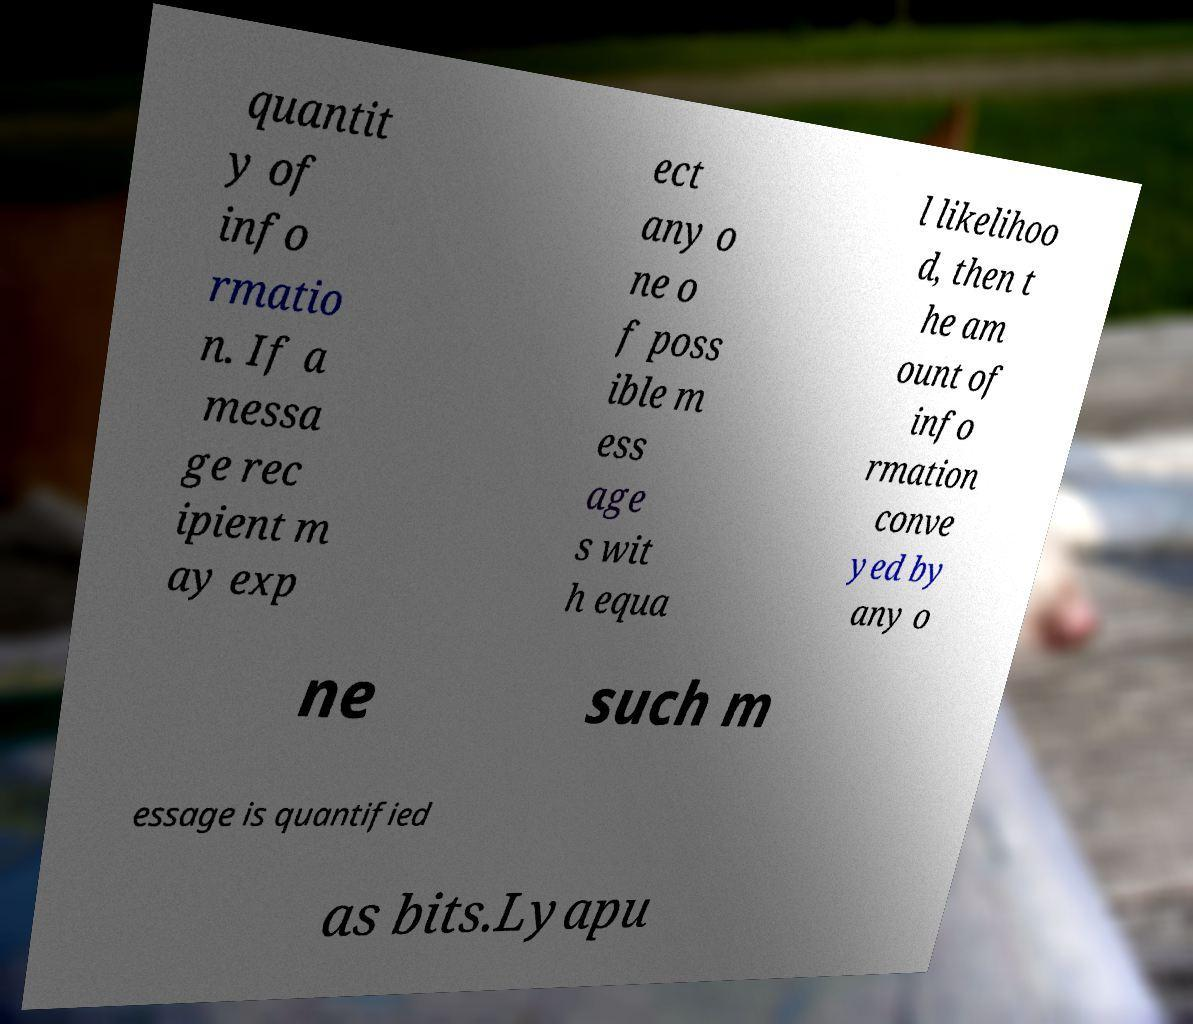There's text embedded in this image that I need extracted. Can you transcribe it verbatim? quantit y of info rmatio n. If a messa ge rec ipient m ay exp ect any o ne o f poss ible m ess age s wit h equa l likelihoo d, then t he am ount of info rmation conve yed by any o ne such m essage is quantified as bits.Lyapu 